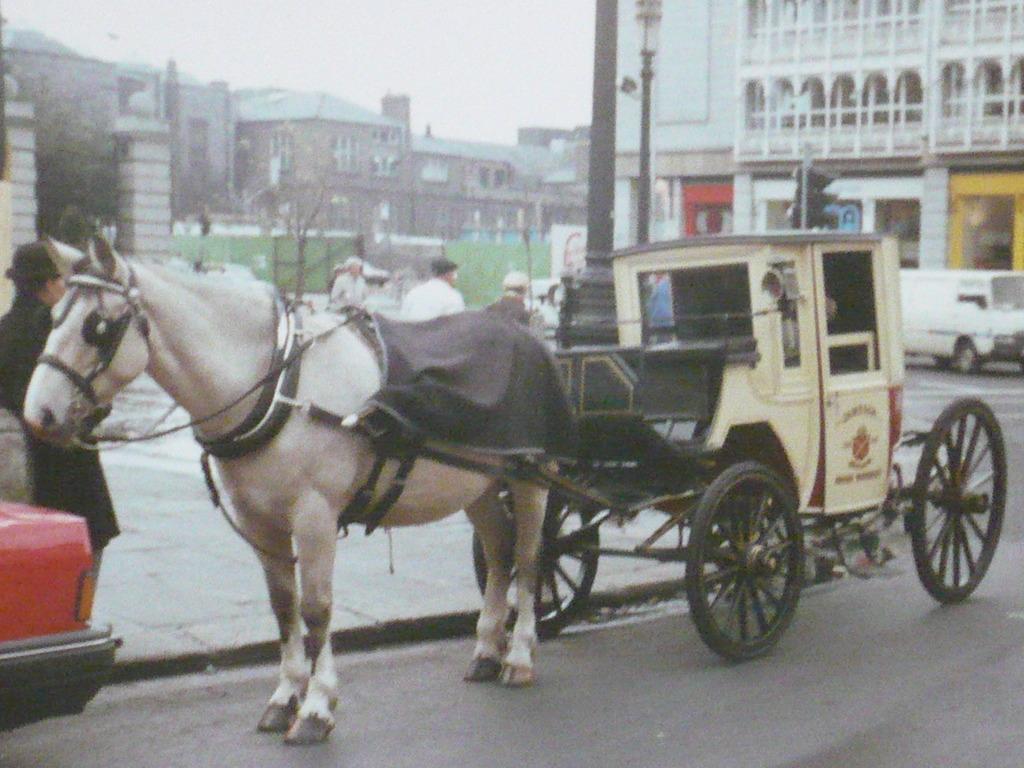Can you describe this image briefly? This is an outside view. Here I can see a horse cart on the road. At the back there are few people on the footpath. In the background there are many buildings. On the right and left side of the image I can see the vehicles on the road. In the middle of the image there is a pole. At the top of the image I can see the sky. 